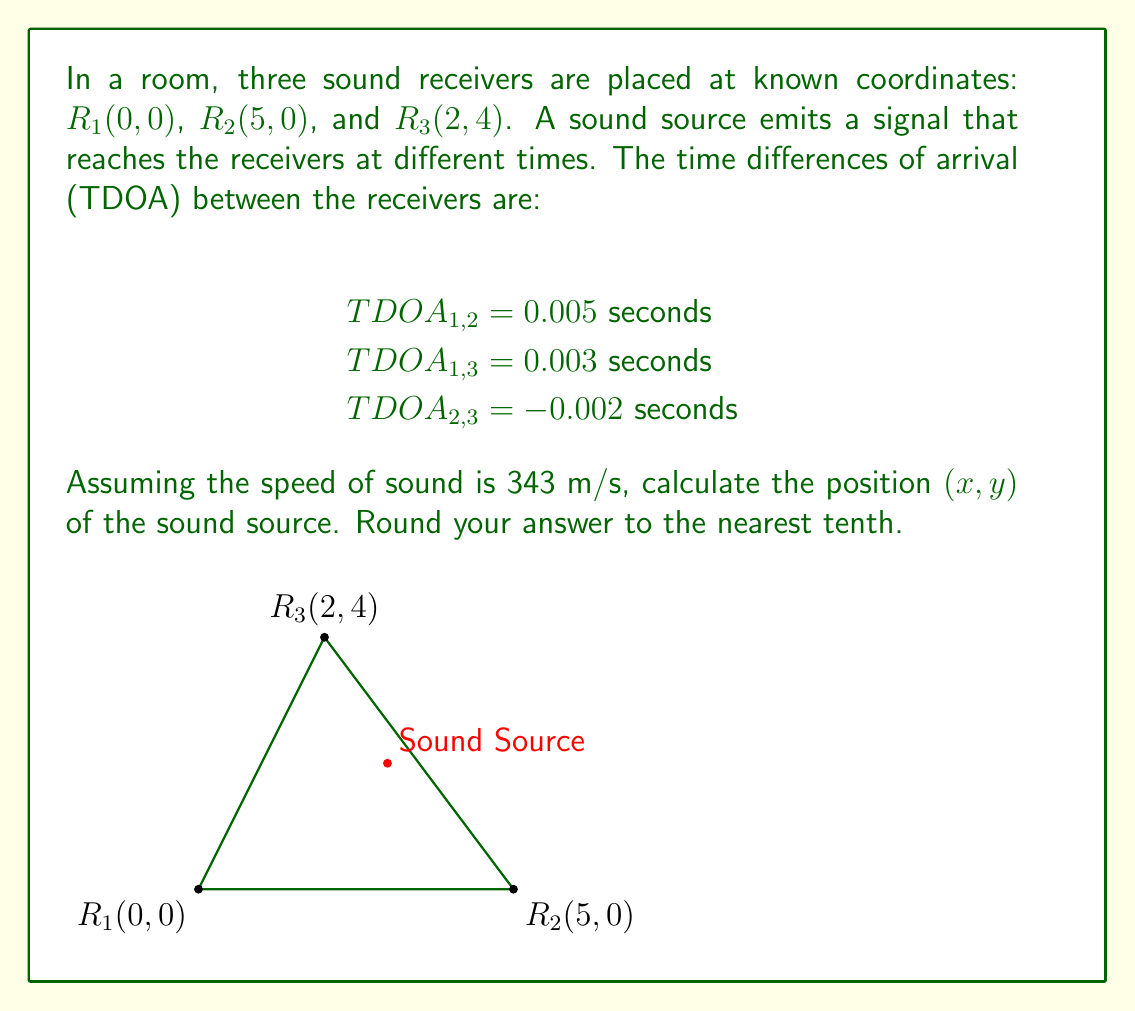Could you help me with this problem? To solve this problem, we'll use the hyperbolic positioning method. The steps are as follows:

1) Convert the TDOA values to distance differences:
   $d_{1,2} = 343 \cdot 0.005 = 1.715$ m
   $d_{1,3} = 343 \cdot 0.003 = 1.029$ m
   $d_{2,3} = 343 \cdot (-0.002) = -0.686$ m

2) Set up the system of equations:
   $\sqrt{x^2 + y^2} - \sqrt{(x-5)^2 + y^2} = 1.715$
   $\sqrt{x^2 + y^2} - \sqrt{(x-2)^2 + (y-4)^2} = 1.029$
   $\sqrt{(x-5)^2 + y^2} - \sqrt{(x-2)^2 + (y-4)^2} = -0.686$

3) This system is nonlinear and can be solved using numerical methods like Newton-Raphson or least squares optimization. Using such methods (which would typically be implemented in software), we find the solution:

   $x \approx 3.0$ m
   $y \approx 2.0$ m

4) We can verify this solution by substituting it back into our original equations:

   $\sqrt{3^2 + 2^2} - \sqrt{(3-5)^2 + 2^2} \approx 1.715$
   $\sqrt{3^2 + 2^2} - \sqrt{(3-2)^2 + (2-4)^2} \approx 1.029$
   $\sqrt{(3-5)^2 + 2^2} - \sqrt{(3-2)^2 + (2-4)^2} \approx -0.686$

These equations hold true (within rounding error), confirming our solution.
Answer: $(3.0, 2.0)$ 